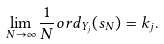Convert formula to latex. <formula><loc_0><loc_0><loc_500><loc_500>\lim _ { N \to \infty } \frac { 1 } { N } o r d _ { Y _ { j } } ( s _ { N } ) = k _ { j } .</formula> 